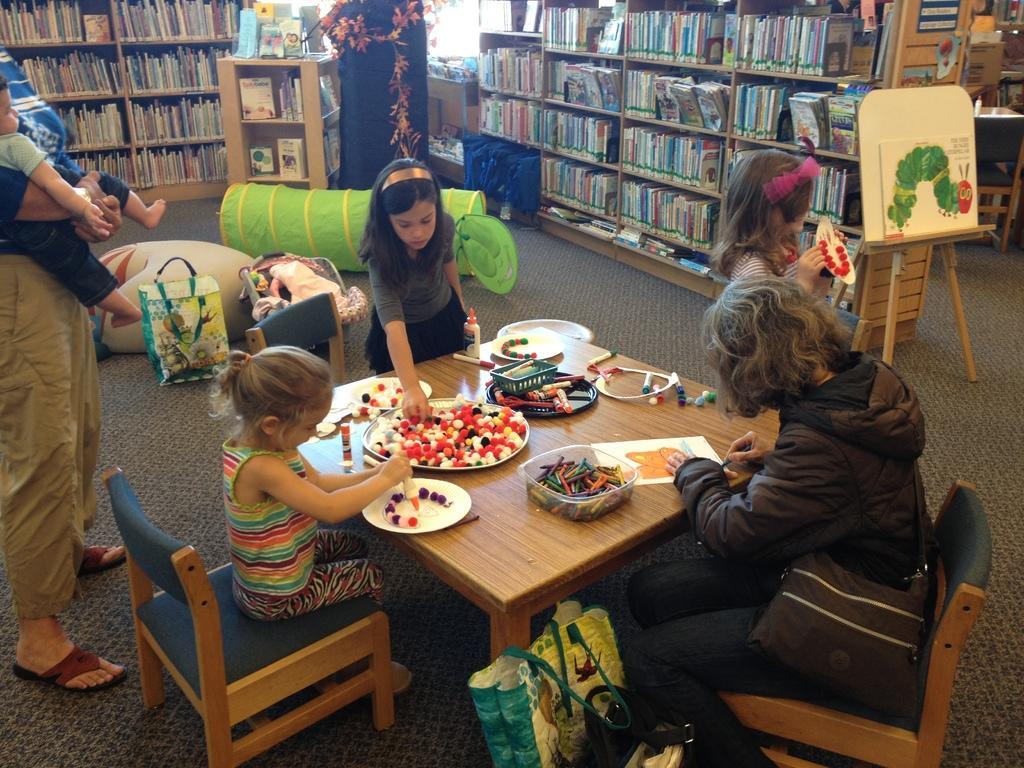Can you describe this image briefly? In this image we can see people sitting on the chairs and standing on the floor and a table is placed in the middle of them. On the table there are stationary items. In the background there are books arranged in the cupboards, decors, toys and a painting canvas. 